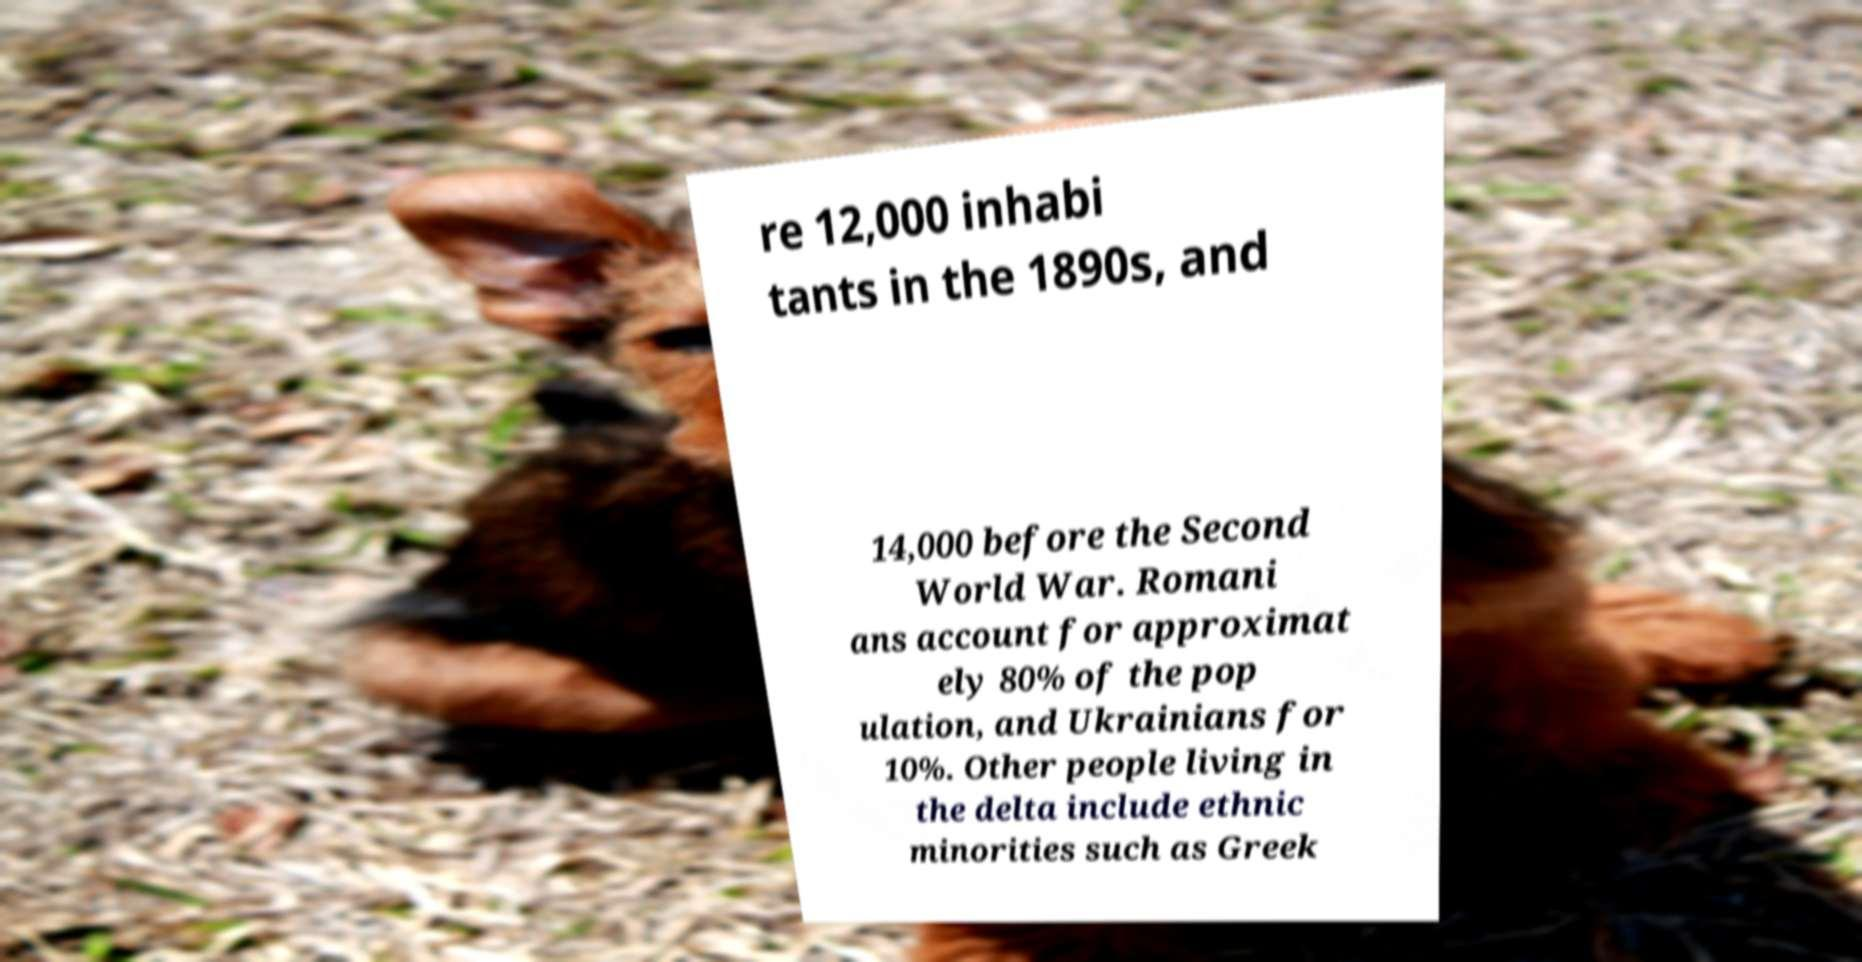Can you accurately transcribe the text from the provided image for me? re 12,000 inhabi tants in the 1890s, and 14,000 before the Second World War. Romani ans account for approximat ely 80% of the pop ulation, and Ukrainians for 10%. Other people living in the delta include ethnic minorities such as Greek 